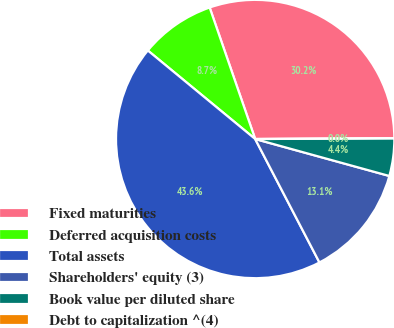Convert chart to OTSL. <chart><loc_0><loc_0><loc_500><loc_500><pie_chart><fcel>Fixed maturities<fcel>Deferred acquisition costs<fcel>Total assets<fcel>Shareholders' equity (3)<fcel>Book value per diluted share<fcel>Debt to capitalization ^(4)<nl><fcel>30.22%<fcel>8.72%<fcel>43.61%<fcel>13.08%<fcel>4.36%<fcel>0.0%<nl></chart> 